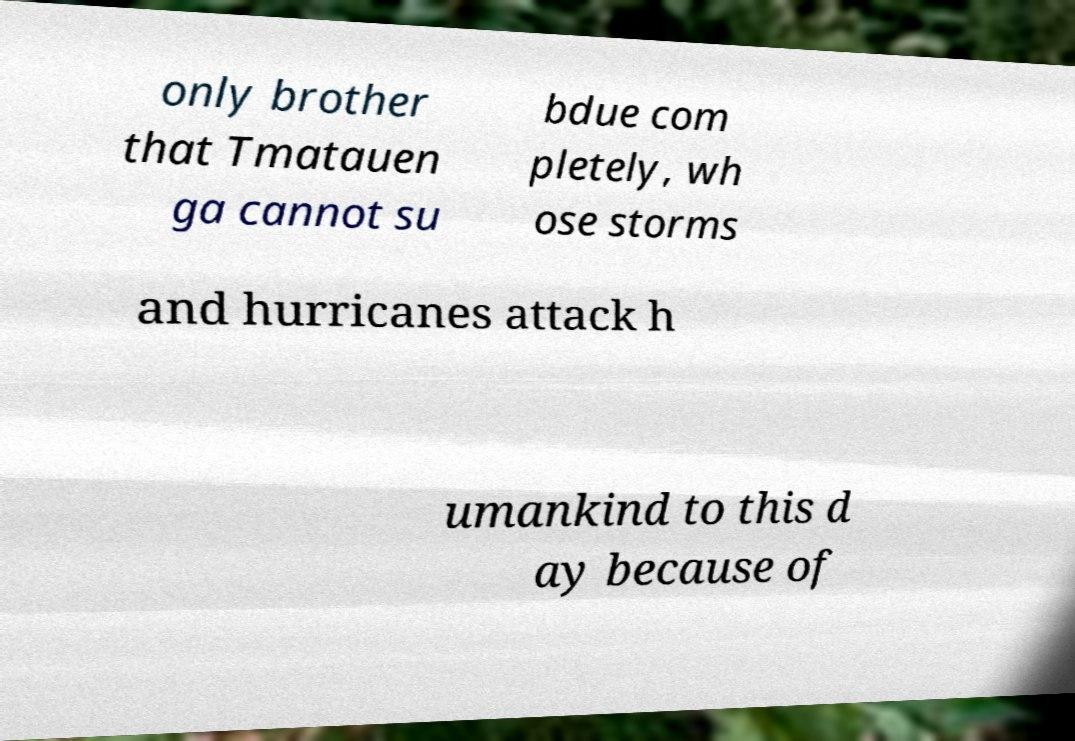Please read and relay the text visible in this image. What does it say? only brother that Tmatauen ga cannot su bdue com pletely, wh ose storms and hurricanes attack h umankind to this d ay because of 